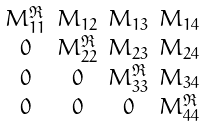<formula> <loc_0><loc_0><loc_500><loc_500>\begin{smallmatrix} \\ M _ { 1 1 } ^ { \Re } & M _ { 1 2 } & M _ { 1 3 } & M _ { 1 4 } \\ 0 & M _ { 2 2 } ^ { \Re } & M _ { 2 3 } & M _ { 2 4 } \\ 0 & 0 & M _ { 3 3 } ^ { \Re } & M _ { 3 4 } \\ 0 & 0 & 0 & M _ { 4 4 } ^ { \Re } \\ \end{smallmatrix}</formula> 